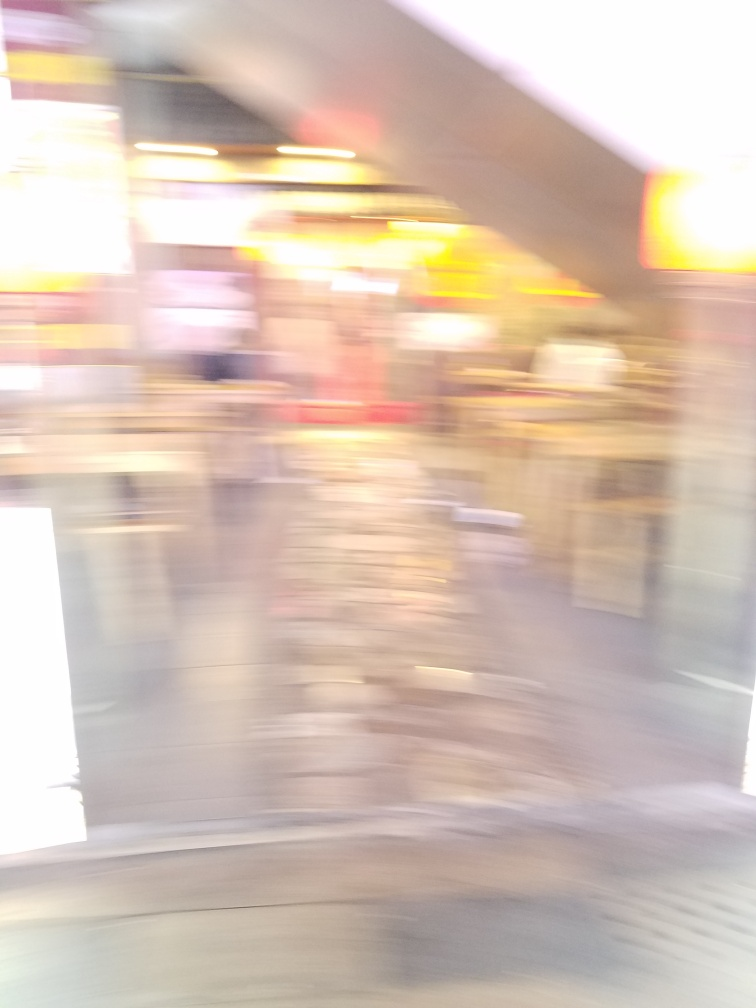Can you describe what might have caused the blurriness in this image? The blurriness in the image is likely due to camera motion or a long exposure time while capturing a moving scene. This can happen if the camera was handheld with an unsteady grip or in a moving vehicle. Another possibility is that the subjects in the image were moving quickly, and a slower shutter speed was unable to freeze the motion. Is there any way to tell what the setting of the photo might be despite the blurriness? It's challenging due to the lack of sharp detail, but the general bright and varied color scheme, along with some vertical structures that could be shelves or stands, suggest it could be an indoor public space like a shopping mall or market. There appears to be a lot of activity, inferred from the multiple streaks and patterns, which supports the idea of a busy public area. 